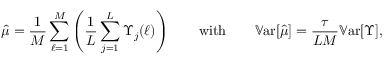Convert formula to latex. <formula><loc_0><loc_0><loc_500><loc_500>\hat { \mu } = \frac { 1 } { M } \sum _ { \ell = 1 } ^ { M } \left ( \frac { 1 } { L } \sum _ { j = 1 } ^ { L } \Upsilon _ { j } ( \ell ) \right ) \quad w i t h \quad \mathbb { V } a r [ \hat { \mu } ] = \frac { \tau } { L M } \mathbb { V } a r [ \Upsilon ] ,</formula> 